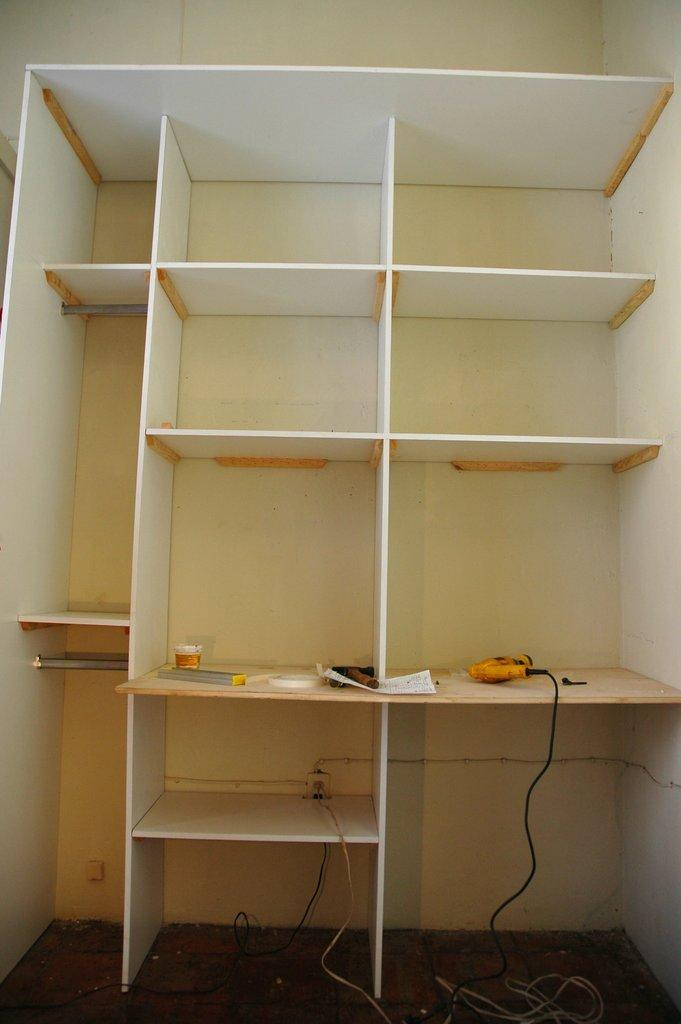What type of furniture is visible in the image? There is a cupboard with racks in the image. What tools can be seen on the cupboard? A drill machine and a hammer are visible on the cupboard. Are there any other items on the cupboard besides the tools? Yes, there are other items on the cupboard. What book is the daughter reading on the cupboard? There is no daughter or book present in the image. How does the soap on the cupboard help with cleaning? There is no soap present on the cupboard in the image. 